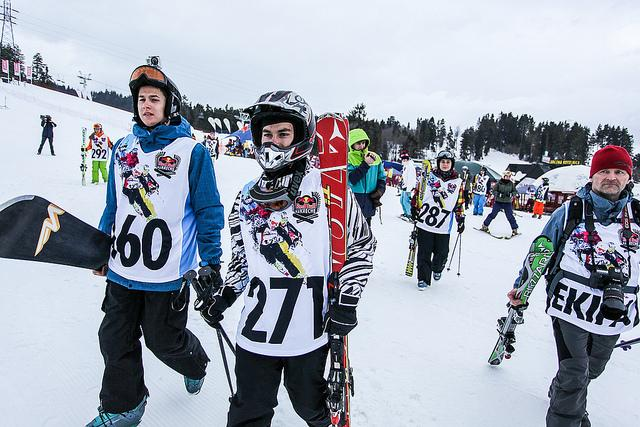WHat kind of competition is taking place?

Choices:
A) snowball
B) skiing
C) ice
D) snowboard skiing 